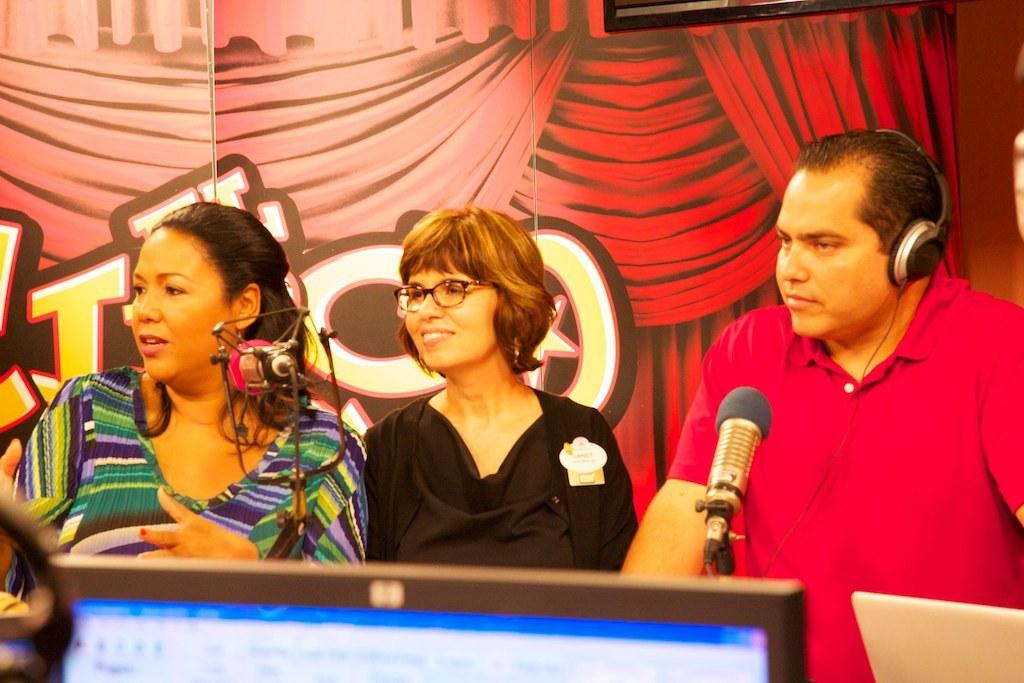How many people are in the image? There are three people in the image: two women and one man. What is the facial expression of the women in the image? The women are smiling in the image. What is the man wearing in the image? The man is wearing a headset in the image. What objects are in front of the people in the image? There are microphones and laptops in front of the people in the image. What can be seen at the back of the people in the image? There are curtains visible at the back of the people in the image. What type of pump is being used by the women in the image? There is no pump present in the image; the women are not using any pump. What type of product are the people in the image producing? The image does not provide information about any product being produced by the people. 